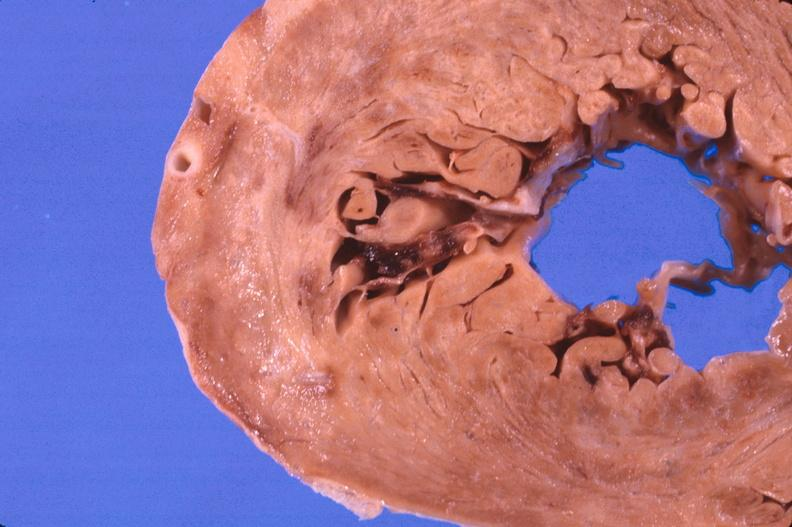where is this?
Answer the question using a single word or phrase. Heart 